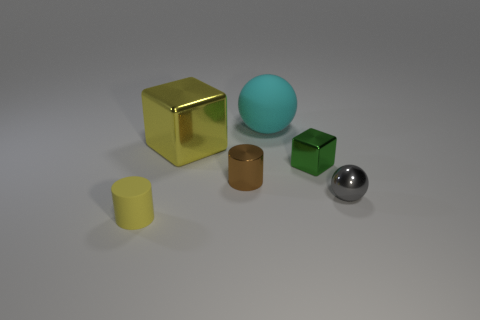Add 1 big brown rubber cylinders. How many objects exist? 7 Add 1 rubber cylinders. How many rubber cylinders are left? 2 Add 1 big yellow cylinders. How many big yellow cylinders exist? 1 Subtract 1 brown cylinders. How many objects are left? 5 Subtract all gray metallic things. Subtract all small brown things. How many objects are left? 4 